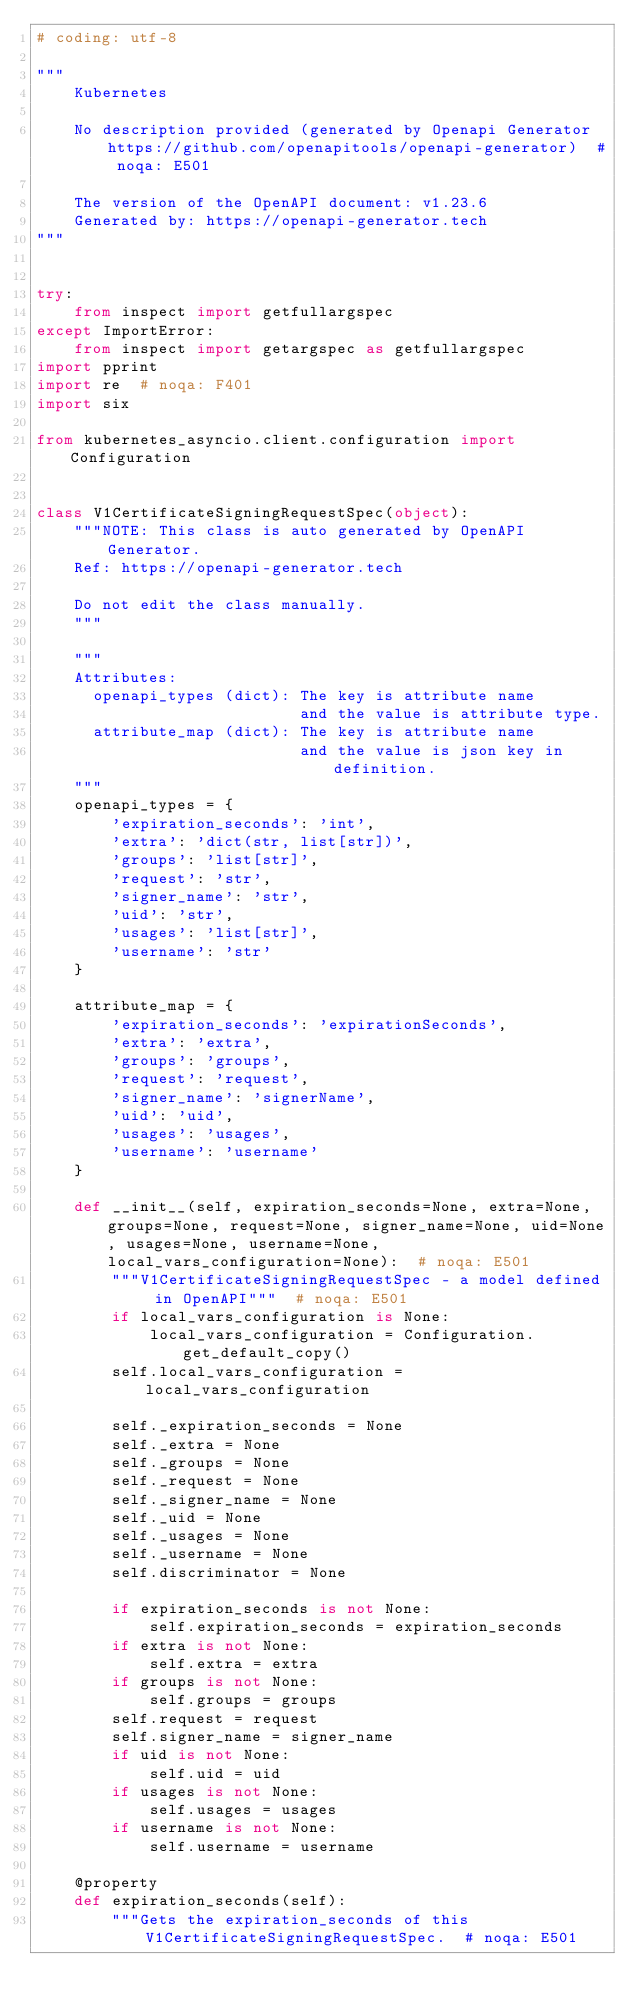<code> <loc_0><loc_0><loc_500><loc_500><_Python_># coding: utf-8

"""
    Kubernetes

    No description provided (generated by Openapi Generator https://github.com/openapitools/openapi-generator)  # noqa: E501

    The version of the OpenAPI document: v1.23.6
    Generated by: https://openapi-generator.tech
"""


try:
    from inspect import getfullargspec
except ImportError:
    from inspect import getargspec as getfullargspec
import pprint
import re  # noqa: F401
import six

from kubernetes_asyncio.client.configuration import Configuration


class V1CertificateSigningRequestSpec(object):
    """NOTE: This class is auto generated by OpenAPI Generator.
    Ref: https://openapi-generator.tech

    Do not edit the class manually.
    """

    """
    Attributes:
      openapi_types (dict): The key is attribute name
                            and the value is attribute type.
      attribute_map (dict): The key is attribute name
                            and the value is json key in definition.
    """
    openapi_types = {
        'expiration_seconds': 'int',
        'extra': 'dict(str, list[str])',
        'groups': 'list[str]',
        'request': 'str',
        'signer_name': 'str',
        'uid': 'str',
        'usages': 'list[str]',
        'username': 'str'
    }

    attribute_map = {
        'expiration_seconds': 'expirationSeconds',
        'extra': 'extra',
        'groups': 'groups',
        'request': 'request',
        'signer_name': 'signerName',
        'uid': 'uid',
        'usages': 'usages',
        'username': 'username'
    }

    def __init__(self, expiration_seconds=None, extra=None, groups=None, request=None, signer_name=None, uid=None, usages=None, username=None, local_vars_configuration=None):  # noqa: E501
        """V1CertificateSigningRequestSpec - a model defined in OpenAPI"""  # noqa: E501
        if local_vars_configuration is None:
            local_vars_configuration = Configuration.get_default_copy()
        self.local_vars_configuration = local_vars_configuration

        self._expiration_seconds = None
        self._extra = None
        self._groups = None
        self._request = None
        self._signer_name = None
        self._uid = None
        self._usages = None
        self._username = None
        self.discriminator = None

        if expiration_seconds is not None:
            self.expiration_seconds = expiration_seconds
        if extra is not None:
            self.extra = extra
        if groups is not None:
            self.groups = groups
        self.request = request
        self.signer_name = signer_name
        if uid is not None:
            self.uid = uid
        if usages is not None:
            self.usages = usages
        if username is not None:
            self.username = username

    @property
    def expiration_seconds(self):
        """Gets the expiration_seconds of this V1CertificateSigningRequestSpec.  # noqa: E501
</code> 